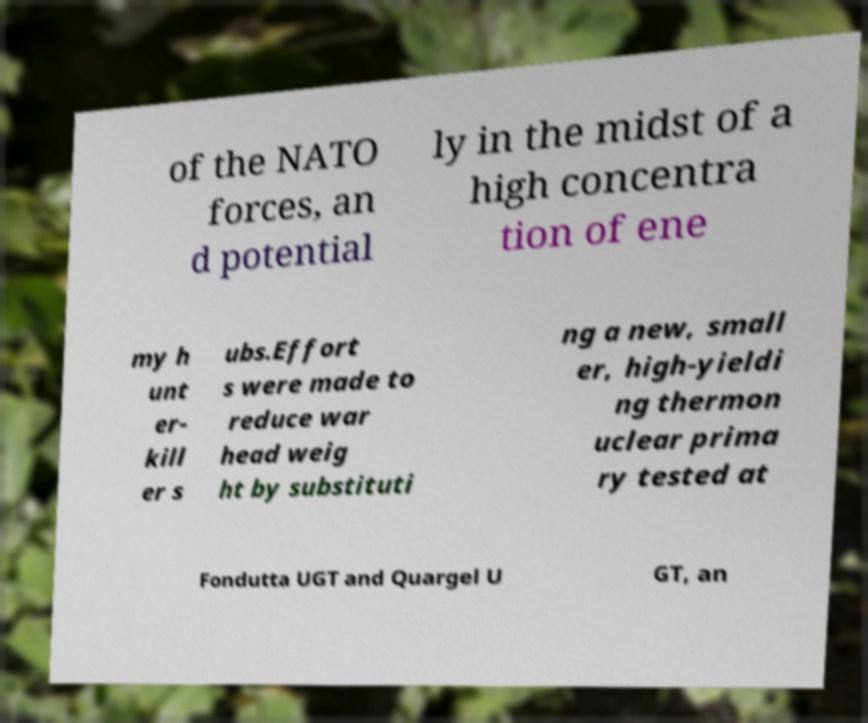Can you read and provide the text displayed in the image?This photo seems to have some interesting text. Can you extract and type it out for me? of the NATO forces, an d potential ly in the midst of a high concentra tion of ene my h unt er- kill er s ubs.Effort s were made to reduce war head weig ht by substituti ng a new, small er, high-yieldi ng thermon uclear prima ry tested at Fondutta UGT and Quargel U GT, an 